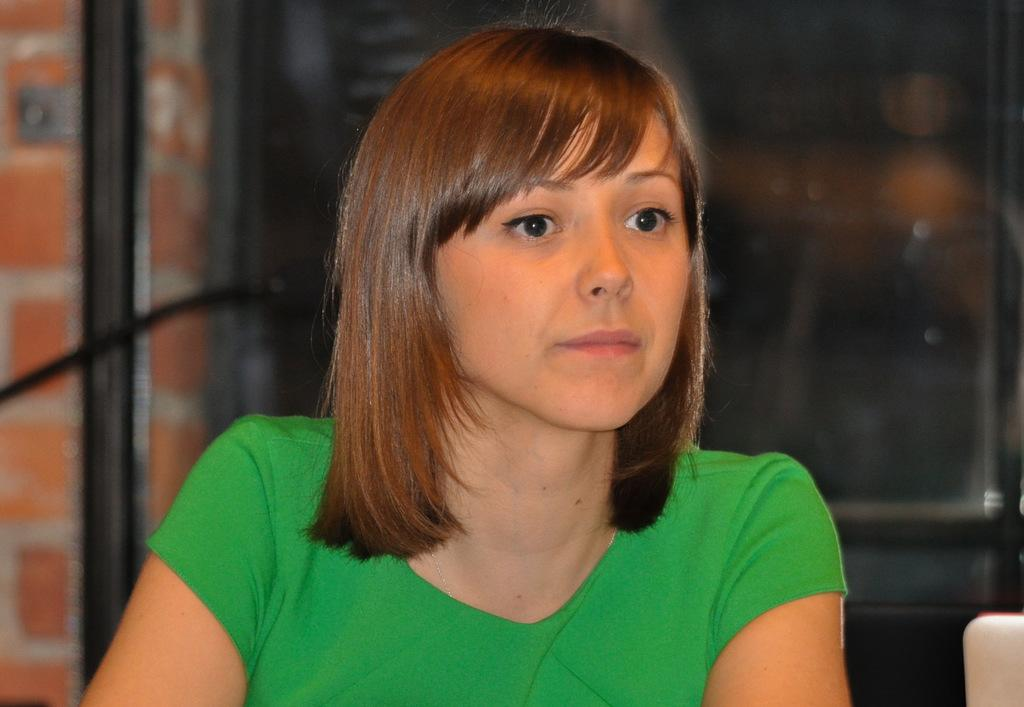Where was the image taken? The image was taken indoors. What can be seen in the background of the image? There is a wall in the background of the image. Who is the main subject in the image? There is a girl in the middle of the image. Can you describe the girl's appearance? The girl has short hair. What time of day is it in the image, based on the presence of a morning connection? There is no mention of a morning connection or any time of day in the image, so it cannot be determined. 